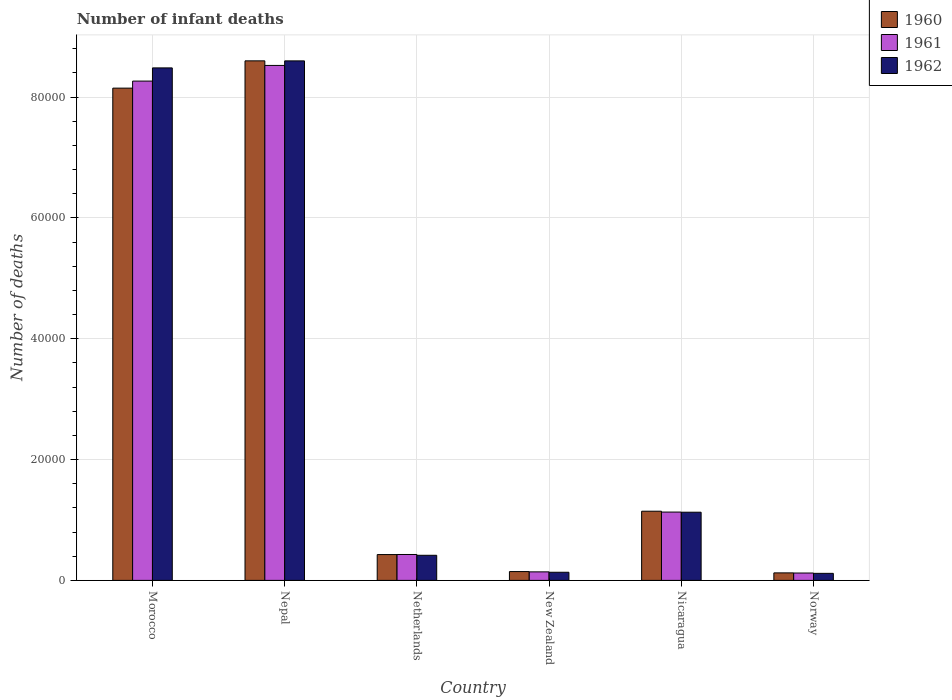How many different coloured bars are there?
Keep it short and to the point. 3. How many groups of bars are there?
Keep it short and to the point. 6. How many bars are there on the 3rd tick from the right?
Offer a terse response. 3. In how many cases, is the number of bars for a given country not equal to the number of legend labels?
Offer a terse response. 0. What is the number of infant deaths in 1962 in Morocco?
Offer a terse response. 8.48e+04. Across all countries, what is the maximum number of infant deaths in 1962?
Provide a succinct answer. 8.60e+04. Across all countries, what is the minimum number of infant deaths in 1961?
Your answer should be very brief. 1220. In which country was the number of infant deaths in 1961 maximum?
Make the answer very short. Nepal. In which country was the number of infant deaths in 1962 minimum?
Your response must be concise. Norway. What is the total number of infant deaths in 1960 in the graph?
Keep it short and to the point. 1.86e+05. What is the difference between the number of infant deaths in 1961 in Morocco and that in Netherlands?
Your answer should be compact. 7.84e+04. What is the difference between the number of infant deaths in 1960 in Norway and the number of infant deaths in 1961 in Nicaragua?
Ensure brevity in your answer.  -1.01e+04. What is the average number of infant deaths in 1962 per country?
Offer a very short reply. 3.15e+04. In how many countries, is the number of infant deaths in 1961 greater than 72000?
Your response must be concise. 2. What is the ratio of the number of infant deaths in 1962 in Morocco to that in Nicaragua?
Make the answer very short. 7.52. Is the number of infant deaths in 1961 in New Zealand less than that in Nicaragua?
Provide a short and direct response. Yes. Is the difference between the number of infant deaths in 1961 in Morocco and Nepal greater than the difference between the number of infant deaths in 1962 in Morocco and Nepal?
Provide a short and direct response. No. What is the difference between the highest and the second highest number of infant deaths in 1961?
Offer a very short reply. -7.14e+04. What is the difference between the highest and the lowest number of infant deaths in 1962?
Provide a succinct answer. 8.48e+04. In how many countries, is the number of infant deaths in 1962 greater than the average number of infant deaths in 1962 taken over all countries?
Ensure brevity in your answer.  2. What does the 1st bar from the left in New Zealand represents?
Give a very brief answer. 1960. What does the 1st bar from the right in Netherlands represents?
Provide a short and direct response. 1962. How many bars are there?
Provide a succinct answer. 18. Are all the bars in the graph horizontal?
Your response must be concise. No. Are the values on the major ticks of Y-axis written in scientific E-notation?
Offer a very short reply. No. Does the graph contain grids?
Make the answer very short. Yes. Where does the legend appear in the graph?
Your answer should be very brief. Top right. How many legend labels are there?
Provide a succinct answer. 3. What is the title of the graph?
Give a very brief answer. Number of infant deaths. What is the label or title of the Y-axis?
Give a very brief answer. Number of deaths. What is the Number of deaths of 1960 in Morocco?
Offer a terse response. 8.15e+04. What is the Number of deaths of 1961 in Morocco?
Offer a terse response. 8.27e+04. What is the Number of deaths of 1962 in Morocco?
Your answer should be compact. 8.48e+04. What is the Number of deaths in 1960 in Nepal?
Your response must be concise. 8.60e+04. What is the Number of deaths of 1961 in Nepal?
Your answer should be very brief. 8.53e+04. What is the Number of deaths of 1962 in Nepal?
Your answer should be compact. 8.60e+04. What is the Number of deaths in 1960 in Netherlands?
Offer a terse response. 4275. What is the Number of deaths of 1961 in Netherlands?
Ensure brevity in your answer.  4288. What is the Number of deaths of 1962 in Netherlands?
Make the answer very short. 4155. What is the Number of deaths in 1960 in New Zealand?
Your answer should be very brief. 1461. What is the Number of deaths of 1961 in New Zealand?
Give a very brief answer. 1412. What is the Number of deaths in 1962 in New Zealand?
Your response must be concise. 1346. What is the Number of deaths of 1960 in Nicaragua?
Your response must be concise. 1.15e+04. What is the Number of deaths in 1961 in Nicaragua?
Keep it short and to the point. 1.13e+04. What is the Number of deaths of 1962 in Nicaragua?
Offer a terse response. 1.13e+04. What is the Number of deaths in 1960 in Norway?
Your answer should be compact. 1243. What is the Number of deaths in 1961 in Norway?
Give a very brief answer. 1220. What is the Number of deaths of 1962 in Norway?
Offer a terse response. 1165. Across all countries, what is the maximum Number of deaths in 1960?
Offer a very short reply. 8.60e+04. Across all countries, what is the maximum Number of deaths of 1961?
Ensure brevity in your answer.  8.53e+04. Across all countries, what is the maximum Number of deaths in 1962?
Your response must be concise. 8.60e+04. Across all countries, what is the minimum Number of deaths of 1960?
Provide a succinct answer. 1243. Across all countries, what is the minimum Number of deaths of 1961?
Your response must be concise. 1220. Across all countries, what is the minimum Number of deaths in 1962?
Give a very brief answer. 1165. What is the total Number of deaths of 1960 in the graph?
Offer a terse response. 1.86e+05. What is the total Number of deaths of 1961 in the graph?
Your answer should be compact. 1.86e+05. What is the total Number of deaths of 1962 in the graph?
Give a very brief answer. 1.89e+05. What is the difference between the Number of deaths in 1960 in Morocco and that in Nepal?
Your response must be concise. -4516. What is the difference between the Number of deaths in 1961 in Morocco and that in Nepal?
Keep it short and to the point. -2593. What is the difference between the Number of deaths of 1962 in Morocco and that in Nepal?
Make the answer very short. -1161. What is the difference between the Number of deaths in 1960 in Morocco and that in Netherlands?
Offer a very short reply. 7.72e+04. What is the difference between the Number of deaths in 1961 in Morocco and that in Netherlands?
Offer a very short reply. 7.84e+04. What is the difference between the Number of deaths in 1962 in Morocco and that in Netherlands?
Your answer should be compact. 8.07e+04. What is the difference between the Number of deaths in 1960 in Morocco and that in New Zealand?
Give a very brief answer. 8.00e+04. What is the difference between the Number of deaths in 1961 in Morocco and that in New Zealand?
Offer a very short reply. 8.12e+04. What is the difference between the Number of deaths in 1962 in Morocco and that in New Zealand?
Your answer should be very brief. 8.35e+04. What is the difference between the Number of deaths in 1960 in Morocco and that in Nicaragua?
Provide a short and direct response. 7.00e+04. What is the difference between the Number of deaths in 1961 in Morocco and that in Nicaragua?
Provide a short and direct response. 7.14e+04. What is the difference between the Number of deaths in 1962 in Morocco and that in Nicaragua?
Provide a succinct answer. 7.36e+04. What is the difference between the Number of deaths of 1960 in Morocco and that in Norway?
Offer a terse response. 8.03e+04. What is the difference between the Number of deaths of 1961 in Morocco and that in Norway?
Offer a terse response. 8.14e+04. What is the difference between the Number of deaths in 1962 in Morocco and that in Norway?
Keep it short and to the point. 8.37e+04. What is the difference between the Number of deaths in 1960 in Nepal and that in Netherlands?
Provide a succinct answer. 8.17e+04. What is the difference between the Number of deaths in 1961 in Nepal and that in Netherlands?
Your answer should be very brief. 8.10e+04. What is the difference between the Number of deaths of 1962 in Nepal and that in Netherlands?
Offer a very short reply. 8.19e+04. What is the difference between the Number of deaths of 1960 in Nepal and that in New Zealand?
Provide a short and direct response. 8.46e+04. What is the difference between the Number of deaths of 1961 in Nepal and that in New Zealand?
Provide a succinct answer. 8.38e+04. What is the difference between the Number of deaths in 1962 in Nepal and that in New Zealand?
Offer a terse response. 8.47e+04. What is the difference between the Number of deaths of 1960 in Nepal and that in Nicaragua?
Make the answer very short. 7.46e+04. What is the difference between the Number of deaths in 1961 in Nepal and that in Nicaragua?
Make the answer very short. 7.39e+04. What is the difference between the Number of deaths of 1962 in Nepal and that in Nicaragua?
Ensure brevity in your answer.  7.47e+04. What is the difference between the Number of deaths in 1960 in Nepal and that in Norway?
Make the answer very short. 8.48e+04. What is the difference between the Number of deaths of 1961 in Nepal and that in Norway?
Your answer should be very brief. 8.40e+04. What is the difference between the Number of deaths of 1962 in Nepal and that in Norway?
Provide a succinct answer. 8.48e+04. What is the difference between the Number of deaths of 1960 in Netherlands and that in New Zealand?
Make the answer very short. 2814. What is the difference between the Number of deaths in 1961 in Netherlands and that in New Zealand?
Keep it short and to the point. 2876. What is the difference between the Number of deaths of 1962 in Netherlands and that in New Zealand?
Your answer should be very brief. 2809. What is the difference between the Number of deaths of 1960 in Netherlands and that in Nicaragua?
Make the answer very short. -7179. What is the difference between the Number of deaths of 1961 in Netherlands and that in Nicaragua?
Offer a terse response. -7022. What is the difference between the Number of deaths in 1962 in Netherlands and that in Nicaragua?
Provide a succinct answer. -7133. What is the difference between the Number of deaths in 1960 in Netherlands and that in Norway?
Give a very brief answer. 3032. What is the difference between the Number of deaths in 1961 in Netherlands and that in Norway?
Give a very brief answer. 3068. What is the difference between the Number of deaths of 1962 in Netherlands and that in Norway?
Offer a terse response. 2990. What is the difference between the Number of deaths of 1960 in New Zealand and that in Nicaragua?
Your response must be concise. -9993. What is the difference between the Number of deaths of 1961 in New Zealand and that in Nicaragua?
Offer a terse response. -9898. What is the difference between the Number of deaths in 1962 in New Zealand and that in Nicaragua?
Offer a terse response. -9942. What is the difference between the Number of deaths of 1960 in New Zealand and that in Norway?
Make the answer very short. 218. What is the difference between the Number of deaths in 1961 in New Zealand and that in Norway?
Offer a very short reply. 192. What is the difference between the Number of deaths of 1962 in New Zealand and that in Norway?
Give a very brief answer. 181. What is the difference between the Number of deaths in 1960 in Nicaragua and that in Norway?
Offer a terse response. 1.02e+04. What is the difference between the Number of deaths in 1961 in Nicaragua and that in Norway?
Your answer should be compact. 1.01e+04. What is the difference between the Number of deaths in 1962 in Nicaragua and that in Norway?
Give a very brief answer. 1.01e+04. What is the difference between the Number of deaths in 1960 in Morocco and the Number of deaths in 1961 in Nepal?
Your answer should be compact. -3759. What is the difference between the Number of deaths in 1960 in Morocco and the Number of deaths in 1962 in Nepal?
Ensure brevity in your answer.  -4511. What is the difference between the Number of deaths of 1961 in Morocco and the Number of deaths of 1962 in Nepal?
Make the answer very short. -3345. What is the difference between the Number of deaths in 1960 in Morocco and the Number of deaths in 1961 in Netherlands?
Provide a short and direct response. 7.72e+04. What is the difference between the Number of deaths of 1960 in Morocco and the Number of deaths of 1962 in Netherlands?
Your response must be concise. 7.73e+04. What is the difference between the Number of deaths of 1961 in Morocco and the Number of deaths of 1962 in Netherlands?
Keep it short and to the point. 7.85e+04. What is the difference between the Number of deaths in 1960 in Morocco and the Number of deaths in 1961 in New Zealand?
Provide a succinct answer. 8.01e+04. What is the difference between the Number of deaths of 1960 in Morocco and the Number of deaths of 1962 in New Zealand?
Provide a succinct answer. 8.01e+04. What is the difference between the Number of deaths of 1961 in Morocco and the Number of deaths of 1962 in New Zealand?
Keep it short and to the point. 8.13e+04. What is the difference between the Number of deaths of 1960 in Morocco and the Number of deaths of 1961 in Nicaragua?
Your answer should be very brief. 7.02e+04. What is the difference between the Number of deaths of 1960 in Morocco and the Number of deaths of 1962 in Nicaragua?
Ensure brevity in your answer.  7.02e+04. What is the difference between the Number of deaths of 1961 in Morocco and the Number of deaths of 1962 in Nicaragua?
Provide a short and direct response. 7.14e+04. What is the difference between the Number of deaths of 1960 in Morocco and the Number of deaths of 1961 in Norway?
Make the answer very short. 8.03e+04. What is the difference between the Number of deaths in 1960 in Morocco and the Number of deaths in 1962 in Norway?
Offer a very short reply. 8.03e+04. What is the difference between the Number of deaths in 1961 in Morocco and the Number of deaths in 1962 in Norway?
Your answer should be compact. 8.15e+04. What is the difference between the Number of deaths of 1960 in Nepal and the Number of deaths of 1961 in Netherlands?
Your answer should be very brief. 8.17e+04. What is the difference between the Number of deaths in 1960 in Nepal and the Number of deaths in 1962 in Netherlands?
Provide a short and direct response. 8.19e+04. What is the difference between the Number of deaths in 1961 in Nepal and the Number of deaths in 1962 in Netherlands?
Keep it short and to the point. 8.11e+04. What is the difference between the Number of deaths in 1960 in Nepal and the Number of deaths in 1961 in New Zealand?
Give a very brief answer. 8.46e+04. What is the difference between the Number of deaths in 1960 in Nepal and the Number of deaths in 1962 in New Zealand?
Your answer should be compact. 8.47e+04. What is the difference between the Number of deaths in 1961 in Nepal and the Number of deaths in 1962 in New Zealand?
Provide a succinct answer. 8.39e+04. What is the difference between the Number of deaths of 1960 in Nepal and the Number of deaths of 1961 in Nicaragua?
Your response must be concise. 7.47e+04. What is the difference between the Number of deaths of 1960 in Nepal and the Number of deaths of 1962 in Nicaragua?
Provide a succinct answer. 7.47e+04. What is the difference between the Number of deaths in 1961 in Nepal and the Number of deaths in 1962 in Nicaragua?
Give a very brief answer. 7.40e+04. What is the difference between the Number of deaths in 1960 in Nepal and the Number of deaths in 1961 in Norway?
Give a very brief answer. 8.48e+04. What is the difference between the Number of deaths in 1960 in Nepal and the Number of deaths in 1962 in Norway?
Ensure brevity in your answer.  8.48e+04. What is the difference between the Number of deaths in 1961 in Nepal and the Number of deaths in 1962 in Norway?
Your answer should be compact. 8.41e+04. What is the difference between the Number of deaths in 1960 in Netherlands and the Number of deaths in 1961 in New Zealand?
Provide a short and direct response. 2863. What is the difference between the Number of deaths in 1960 in Netherlands and the Number of deaths in 1962 in New Zealand?
Your answer should be compact. 2929. What is the difference between the Number of deaths in 1961 in Netherlands and the Number of deaths in 1962 in New Zealand?
Give a very brief answer. 2942. What is the difference between the Number of deaths of 1960 in Netherlands and the Number of deaths of 1961 in Nicaragua?
Provide a short and direct response. -7035. What is the difference between the Number of deaths in 1960 in Netherlands and the Number of deaths in 1962 in Nicaragua?
Keep it short and to the point. -7013. What is the difference between the Number of deaths of 1961 in Netherlands and the Number of deaths of 1962 in Nicaragua?
Ensure brevity in your answer.  -7000. What is the difference between the Number of deaths of 1960 in Netherlands and the Number of deaths of 1961 in Norway?
Provide a short and direct response. 3055. What is the difference between the Number of deaths in 1960 in Netherlands and the Number of deaths in 1962 in Norway?
Ensure brevity in your answer.  3110. What is the difference between the Number of deaths of 1961 in Netherlands and the Number of deaths of 1962 in Norway?
Keep it short and to the point. 3123. What is the difference between the Number of deaths of 1960 in New Zealand and the Number of deaths of 1961 in Nicaragua?
Your answer should be very brief. -9849. What is the difference between the Number of deaths in 1960 in New Zealand and the Number of deaths in 1962 in Nicaragua?
Ensure brevity in your answer.  -9827. What is the difference between the Number of deaths in 1961 in New Zealand and the Number of deaths in 1962 in Nicaragua?
Your answer should be very brief. -9876. What is the difference between the Number of deaths in 1960 in New Zealand and the Number of deaths in 1961 in Norway?
Offer a very short reply. 241. What is the difference between the Number of deaths of 1960 in New Zealand and the Number of deaths of 1962 in Norway?
Offer a terse response. 296. What is the difference between the Number of deaths of 1961 in New Zealand and the Number of deaths of 1962 in Norway?
Give a very brief answer. 247. What is the difference between the Number of deaths in 1960 in Nicaragua and the Number of deaths in 1961 in Norway?
Offer a very short reply. 1.02e+04. What is the difference between the Number of deaths of 1960 in Nicaragua and the Number of deaths of 1962 in Norway?
Offer a terse response. 1.03e+04. What is the difference between the Number of deaths in 1961 in Nicaragua and the Number of deaths in 1962 in Norway?
Your answer should be compact. 1.01e+04. What is the average Number of deaths of 1960 per country?
Your answer should be very brief. 3.10e+04. What is the average Number of deaths of 1961 per country?
Offer a very short reply. 3.10e+04. What is the average Number of deaths in 1962 per country?
Offer a very short reply. 3.15e+04. What is the difference between the Number of deaths of 1960 and Number of deaths of 1961 in Morocco?
Provide a succinct answer. -1166. What is the difference between the Number of deaths of 1960 and Number of deaths of 1962 in Morocco?
Provide a short and direct response. -3350. What is the difference between the Number of deaths of 1961 and Number of deaths of 1962 in Morocco?
Your response must be concise. -2184. What is the difference between the Number of deaths in 1960 and Number of deaths in 1961 in Nepal?
Offer a terse response. 757. What is the difference between the Number of deaths in 1960 and Number of deaths in 1962 in Nepal?
Provide a succinct answer. 5. What is the difference between the Number of deaths of 1961 and Number of deaths of 1962 in Nepal?
Give a very brief answer. -752. What is the difference between the Number of deaths in 1960 and Number of deaths in 1962 in Netherlands?
Your answer should be compact. 120. What is the difference between the Number of deaths in 1961 and Number of deaths in 1962 in Netherlands?
Make the answer very short. 133. What is the difference between the Number of deaths in 1960 and Number of deaths in 1962 in New Zealand?
Offer a terse response. 115. What is the difference between the Number of deaths in 1961 and Number of deaths in 1962 in New Zealand?
Make the answer very short. 66. What is the difference between the Number of deaths of 1960 and Number of deaths of 1961 in Nicaragua?
Provide a short and direct response. 144. What is the difference between the Number of deaths in 1960 and Number of deaths in 1962 in Nicaragua?
Provide a short and direct response. 166. What is the difference between the Number of deaths in 1961 and Number of deaths in 1962 in Nicaragua?
Provide a short and direct response. 22. What is the difference between the Number of deaths of 1961 and Number of deaths of 1962 in Norway?
Provide a short and direct response. 55. What is the ratio of the Number of deaths in 1960 in Morocco to that in Nepal?
Give a very brief answer. 0.95. What is the ratio of the Number of deaths of 1961 in Morocco to that in Nepal?
Your answer should be very brief. 0.97. What is the ratio of the Number of deaths in 1962 in Morocco to that in Nepal?
Offer a terse response. 0.99. What is the ratio of the Number of deaths of 1960 in Morocco to that in Netherlands?
Provide a succinct answer. 19.06. What is the ratio of the Number of deaths in 1961 in Morocco to that in Netherlands?
Your answer should be very brief. 19.28. What is the ratio of the Number of deaths in 1962 in Morocco to that in Netherlands?
Offer a terse response. 20.42. What is the ratio of the Number of deaths of 1960 in Morocco to that in New Zealand?
Give a very brief answer. 55.78. What is the ratio of the Number of deaths of 1961 in Morocco to that in New Zealand?
Your answer should be very brief. 58.54. What is the ratio of the Number of deaths in 1962 in Morocco to that in New Zealand?
Provide a succinct answer. 63.03. What is the ratio of the Number of deaths in 1960 in Morocco to that in Nicaragua?
Your answer should be very brief. 7.12. What is the ratio of the Number of deaths in 1961 in Morocco to that in Nicaragua?
Your answer should be very brief. 7.31. What is the ratio of the Number of deaths of 1962 in Morocco to that in Nicaragua?
Ensure brevity in your answer.  7.52. What is the ratio of the Number of deaths of 1960 in Morocco to that in Norway?
Keep it short and to the point. 65.56. What is the ratio of the Number of deaths of 1961 in Morocco to that in Norway?
Your answer should be compact. 67.75. What is the ratio of the Number of deaths of 1962 in Morocco to that in Norway?
Your response must be concise. 72.83. What is the ratio of the Number of deaths in 1960 in Nepal to that in Netherlands?
Give a very brief answer. 20.12. What is the ratio of the Number of deaths of 1961 in Nepal to that in Netherlands?
Offer a very short reply. 19.88. What is the ratio of the Number of deaths of 1962 in Nepal to that in Netherlands?
Make the answer very short. 20.7. What is the ratio of the Number of deaths in 1960 in Nepal to that in New Zealand?
Keep it short and to the point. 58.87. What is the ratio of the Number of deaths in 1961 in Nepal to that in New Zealand?
Your response must be concise. 60.38. What is the ratio of the Number of deaths in 1962 in Nepal to that in New Zealand?
Provide a succinct answer. 63.9. What is the ratio of the Number of deaths in 1960 in Nepal to that in Nicaragua?
Provide a short and direct response. 7.51. What is the ratio of the Number of deaths of 1961 in Nepal to that in Nicaragua?
Keep it short and to the point. 7.54. What is the ratio of the Number of deaths in 1962 in Nepal to that in Nicaragua?
Your response must be concise. 7.62. What is the ratio of the Number of deaths of 1960 in Nepal to that in Norway?
Ensure brevity in your answer.  69.2. What is the ratio of the Number of deaths in 1961 in Nepal to that in Norway?
Offer a terse response. 69.88. What is the ratio of the Number of deaths in 1962 in Nepal to that in Norway?
Give a very brief answer. 73.82. What is the ratio of the Number of deaths of 1960 in Netherlands to that in New Zealand?
Your answer should be very brief. 2.93. What is the ratio of the Number of deaths in 1961 in Netherlands to that in New Zealand?
Your response must be concise. 3.04. What is the ratio of the Number of deaths in 1962 in Netherlands to that in New Zealand?
Your response must be concise. 3.09. What is the ratio of the Number of deaths of 1960 in Netherlands to that in Nicaragua?
Your response must be concise. 0.37. What is the ratio of the Number of deaths in 1961 in Netherlands to that in Nicaragua?
Offer a very short reply. 0.38. What is the ratio of the Number of deaths of 1962 in Netherlands to that in Nicaragua?
Provide a succinct answer. 0.37. What is the ratio of the Number of deaths in 1960 in Netherlands to that in Norway?
Your response must be concise. 3.44. What is the ratio of the Number of deaths of 1961 in Netherlands to that in Norway?
Provide a short and direct response. 3.51. What is the ratio of the Number of deaths in 1962 in Netherlands to that in Norway?
Your response must be concise. 3.57. What is the ratio of the Number of deaths of 1960 in New Zealand to that in Nicaragua?
Keep it short and to the point. 0.13. What is the ratio of the Number of deaths in 1961 in New Zealand to that in Nicaragua?
Your answer should be compact. 0.12. What is the ratio of the Number of deaths of 1962 in New Zealand to that in Nicaragua?
Your answer should be compact. 0.12. What is the ratio of the Number of deaths in 1960 in New Zealand to that in Norway?
Your answer should be compact. 1.18. What is the ratio of the Number of deaths of 1961 in New Zealand to that in Norway?
Your answer should be very brief. 1.16. What is the ratio of the Number of deaths in 1962 in New Zealand to that in Norway?
Ensure brevity in your answer.  1.16. What is the ratio of the Number of deaths in 1960 in Nicaragua to that in Norway?
Ensure brevity in your answer.  9.21. What is the ratio of the Number of deaths of 1961 in Nicaragua to that in Norway?
Provide a short and direct response. 9.27. What is the ratio of the Number of deaths in 1962 in Nicaragua to that in Norway?
Provide a succinct answer. 9.69. What is the difference between the highest and the second highest Number of deaths in 1960?
Offer a very short reply. 4516. What is the difference between the highest and the second highest Number of deaths of 1961?
Keep it short and to the point. 2593. What is the difference between the highest and the second highest Number of deaths of 1962?
Your response must be concise. 1161. What is the difference between the highest and the lowest Number of deaths of 1960?
Make the answer very short. 8.48e+04. What is the difference between the highest and the lowest Number of deaths of 1961?
Give a very brief answer. 8.40e+04. What is the difference between the highest and the lowest Number of deaths of 1962?
Keep it short and to the point. 8.48e+04. 